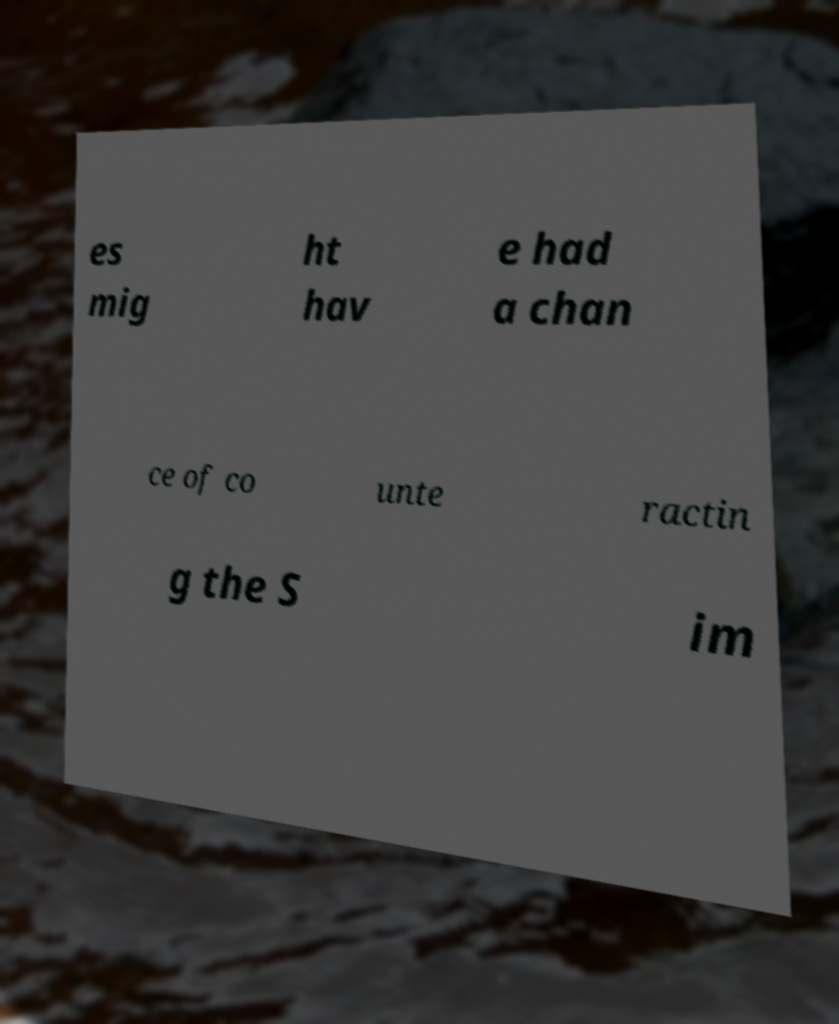Please read and relay the text visible in this image. What does it say? es mig ht hav e had a chan ce of co unte ractin g the S im 